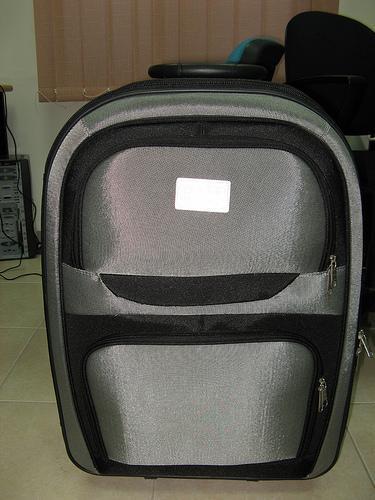How many zippers are on the luggage?
Give a very brief answer. 3. 